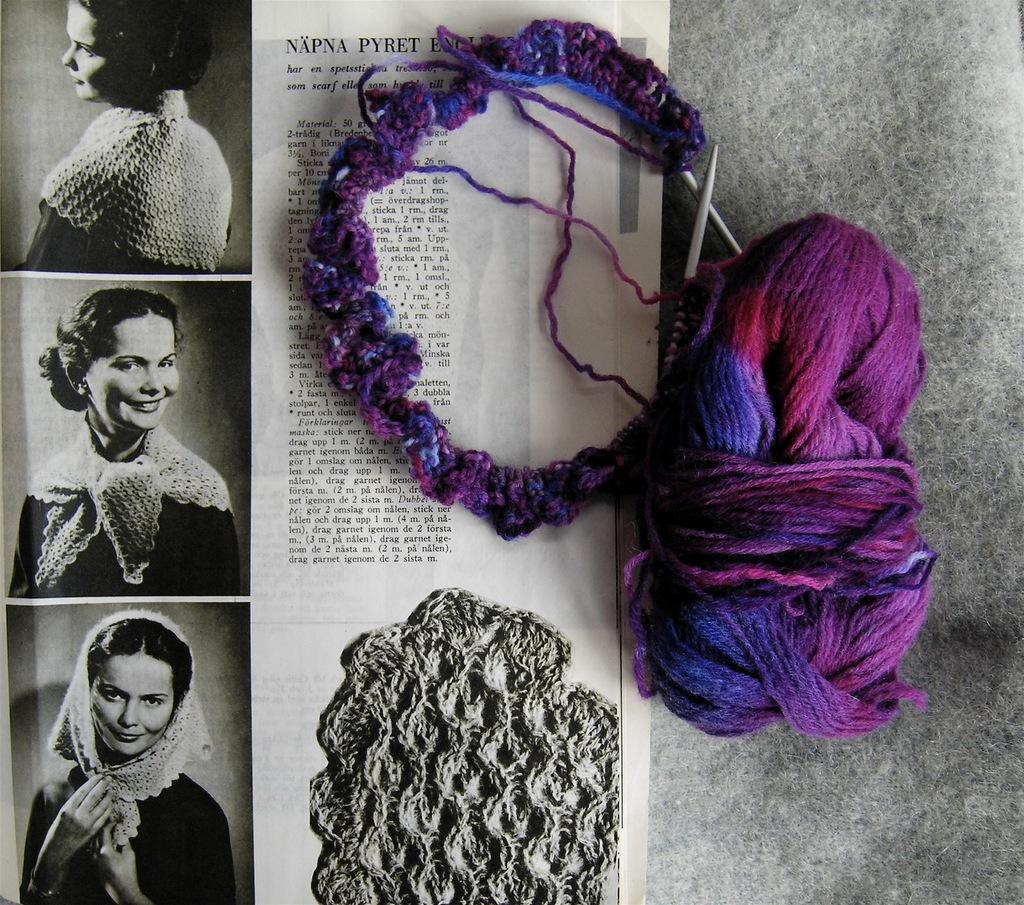What material is located on the right side of the image? There is wool on the right side of the image. What object is associated with the wool in the image? There is a wool stick on the right side of the image. What is on the left side of the image? There is a paper on the left side of the image. What can be seen on the paper? There are persons present on the paper, and text is visible on the paper. How does the wool compare to the mass of the persons on the paper? The wool and the persons on the paper are separate entities, and there is no comparison of mass between them in the image. Are the persons on the paper sleeping in the image? There is no indication of the persons' state of sleep in the image; they are simply depicted on the paper. 